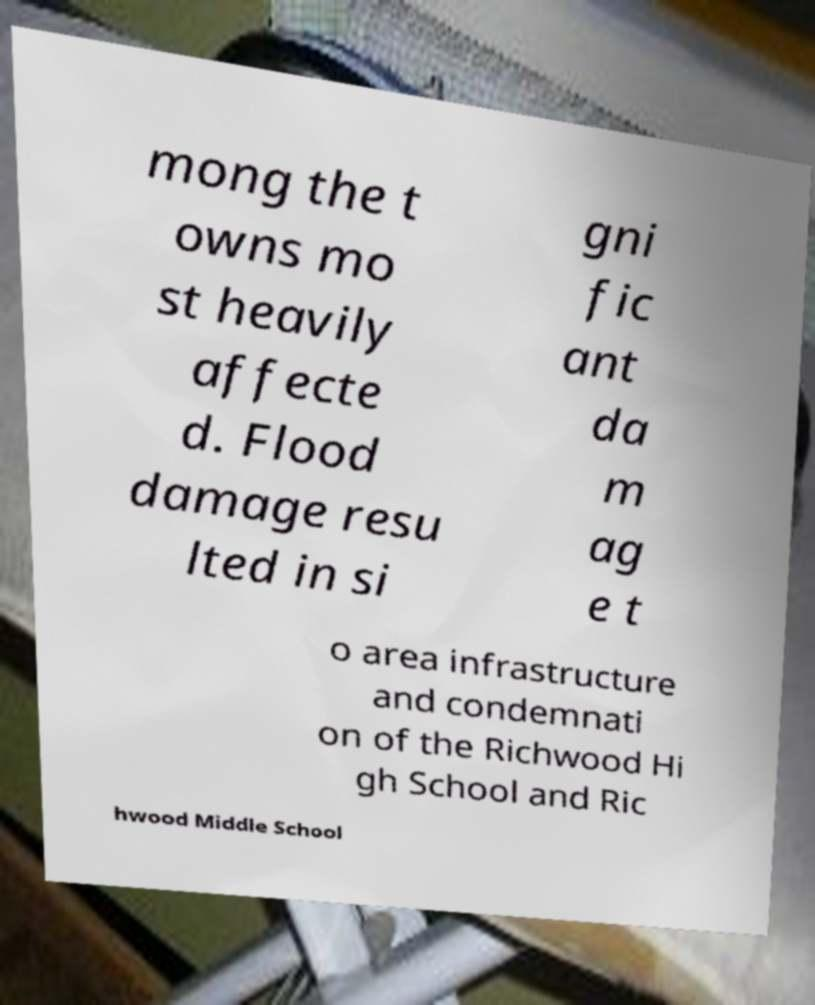Could you extract and type out the text from this image? mong the t owns mo st heavily affecte d. Flood damage resu lted in si gni fic ant da m ag e t o area infrastructure and condemnati on of the Richwood Hi gh School and Ric hwood Middle School 